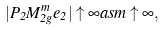Convert formula to latex. <formula><loc_0><loc_0><loc_500><loc_500>| P _ { 2 } M _ { 2 g } ^ { m } e _ { 2 } | \uparrow \infty a s m \uparrow \infty ,</formula> 